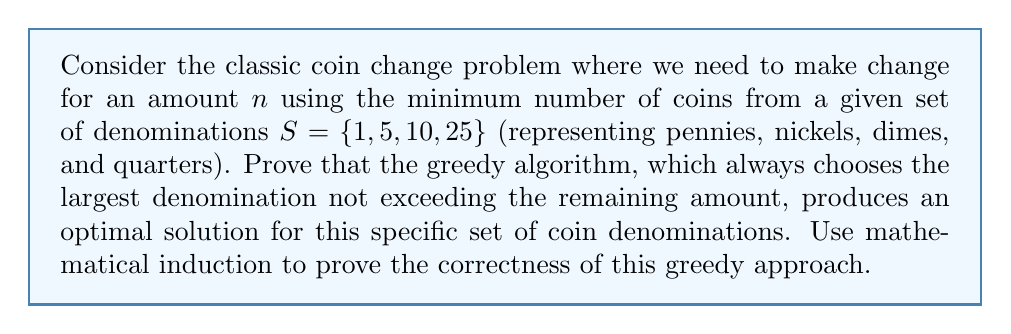Solve this math problem. To prove the correctness of the greedy algorithm for this coin change problem, we will use mathematical induction on the amount $n$. We will show that the greedy algorithm produces an optimal solution for all $n \geq 1$.

Base case: For $n = 1$, the greedy algorithm chooses one penny, which is clearly optimal.

Inductive hypothesis: Assume the greedy algorithm produces an optimal solution for all amounts less than or equal to $k$, where $k \geq 1$.

Inductive step: We need to prove that the greedy algorithm produces an optimal solution for $k+1$.

Let $G(n)$ be the number of coins used by the greedy algorithm for amount $n$, and $O(n)$ be the optimal number of coins for amount $n$.

Case 1: If $k+1$ is divisible by 25, then $G(k+1) = G(k-24) + 1$, as the greedy algorithm will use one quarter and the optimal solution for the remaining amount.
By the inductive hypothesis, $G(k-24) = O(k-24)$, so $G(k+1) = O(k-24) + 1 = O(k+1)$.

Case 2: If $k+1$ leaves a remainder of $r$ when divided by 25, where $0 < r < 25$, then:

a) If $10 \leq r < 25$, the greedy algorithm uses one dime and the optimal solution for $k-9$.
$G(k+1) = G(k-9) + 1 = O(k-9) + 1 = O(k+1)$

b) If $5 \leq r < 10$, the greedy algorithm uses one nickel and the optimal solution for $k-4$.
$G(k+1) = G(k-4) + 1 = O(k-4) + 1 = O(k+1)$

c) If $1 \leq r < 5$, the greedy algorithm uses $r$ pennies and the optimal solution for $k+1-r$.
$G(k+1) = G(k+1-r) + r = O(k+1-r) + r = O(k+1)$

In all cases, we have shown that $G(k+1) = O(k+1)$, proving that the greedy algorithm produces an optimal solution for $k+1$.

By the principle of mathematical induction, we have proved that the greedy algorithm produces an optimal solution for all $n \geq 1$.
Answer: The greedy algorithm for the coin change problem with denominations $S = \{1, 5, 10, 25\}$ is proven to be optimal for all $n \geq 1$ by mathematical induction. 